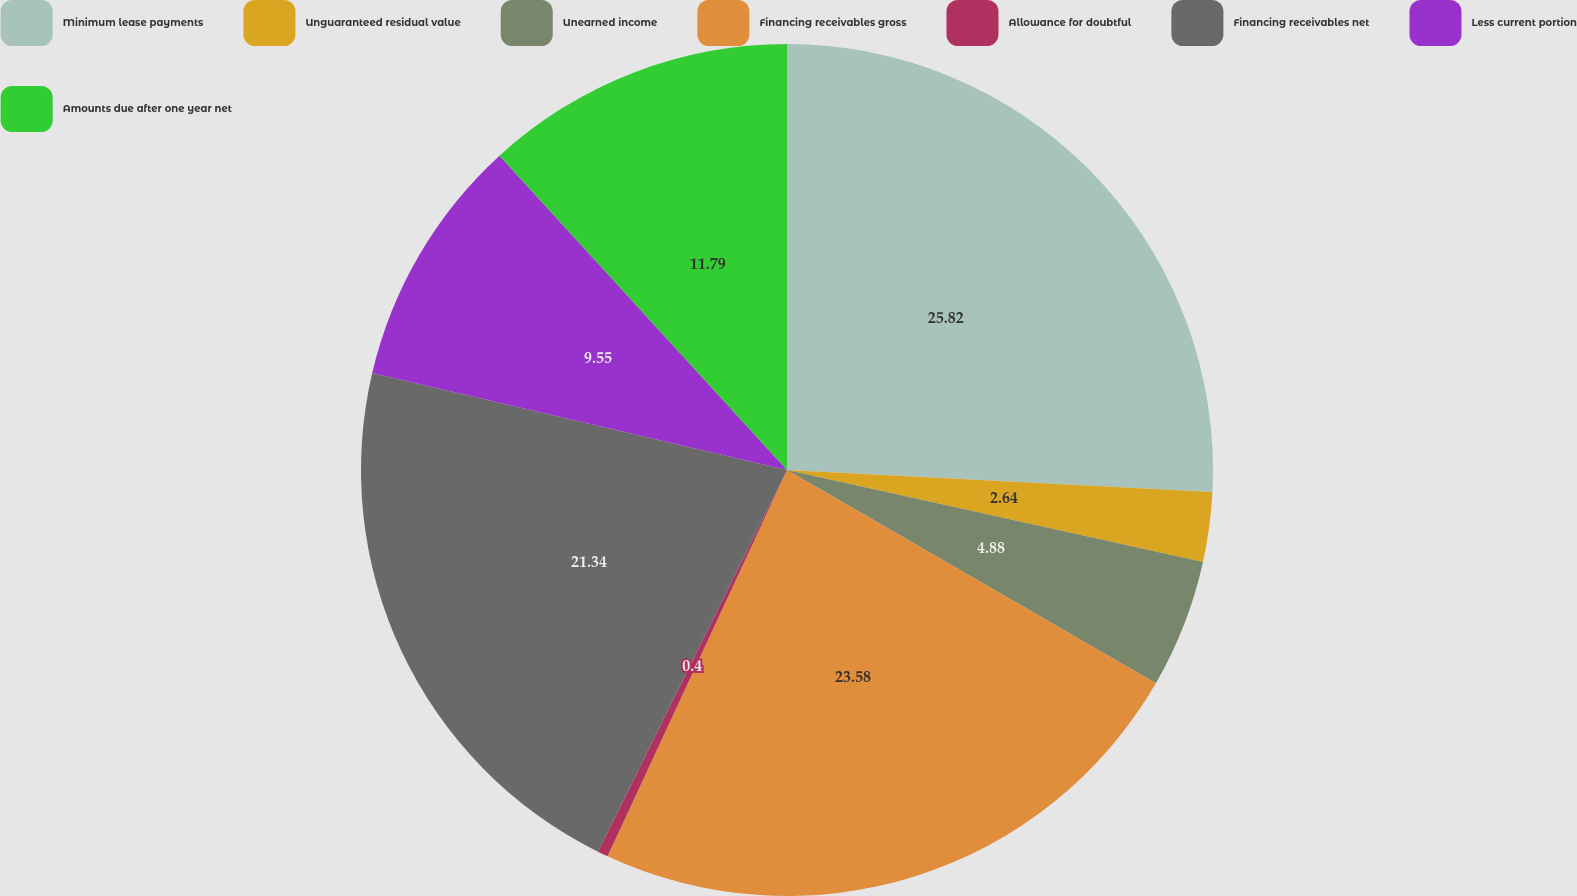Convert chart to OTSL. <chart><loc_0><loc_0><loc_500><loc_500><pie_chart><fcel>Minimum lease payments<fcel>Unguaranteed residual value<fcel>Unearned income<fcel>Financing receivables gross<fcel>Allowance for doubtful<fcel>Financing receivables net<fcel>Less current portion<fcel>Amounts due after one year net<nl><fcel>25.82%<fcel>2.64%<fcel>4.88%<fcel>23.58%<fcel>0.4%<fcel>21.34%<fcel>9.55%<fcel>11.79%<nl></chart> 